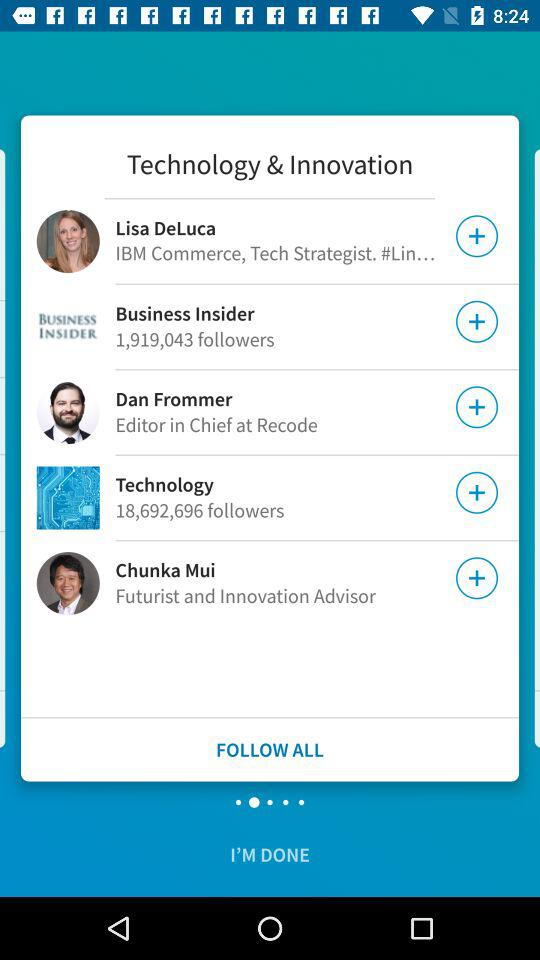What is the count of followers of "Technology"? The count of followers is 18,692,696. 